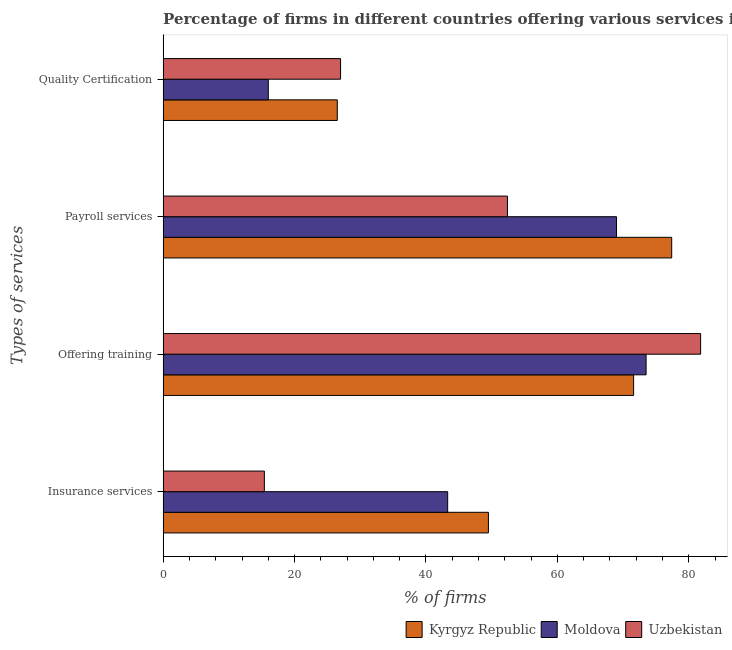How many bars are there on the 2nd tick from the bottom?
Offer a very short reply. 3. What is the label of the 4th group of bars from the top?
Give a very brief answer. Insurance services. What is the percentage of firms offering payroll services in Uzbekistan?
Keep it short and to the point. 52.4. Across all countries, what is the maximum percentage of firms offering payroll services?
Offer a terse response. 77.4. Across all countries, what is the minimum percentage of firms offering payroll services?
Keep it short and to the point. 52.4. In which country was the percentage of firms offering insurance services maximum?
Offer a terse response. Kyrgyz Republic. In which country was the percentage of firms offering quality certification minimum?
Your answer should be compact. Moldova. What is the total percentage of firms offering quality certification in the graph?
Your answer should be compact. 69.5. What is the difference between the percentage of firms offering training in Uzbekistan and that in Moldova?
Offer a terse response. 8.3. What is the average percentage of firms offering payroll services per country?
Keep it short and to the point. 66.27. What is the difference between the percentage of firms offering training and percentage of firms offering payroll services in Kyrgyz Republic?
Provide a succinct answer. -5.8. What is the ratio of the percentage of firms offering quality certification in Uzbekistan to that in Kyrgyz Republic?
Make the answer very short. 1.02. What is the difference between the highest and the second highest percentage of firms offering training?
Your answer should be compact. 8.3. What is the difference between the highest and the lowest percentage of firms offering training?
Ensure brevity in your answer.  10.2. Is the sum of the percentage of firms offering payroll services in Kyrgyz Republic and Moldova greater than the maximum percentage of firms offering quality certification across all countries?
Give a very brief answer. Yes. Is it the case that in every country, the sum of the percentage of firms offering quality certification and percentage of firms offering insurance services is greater than the sum of percentage of firms offering training and percentage of firms offering payroll services?
Your response must be concise. No. What does the 3rd bar from the top in Insurance services represents?
Ensure brevity in your answer.  Kyrgyz Republic. What does the 1st bar from the bottom in Payroll services represents?
Offer a terse response. Kyrgyz Republic. Is it the case that in every country, the sum of the percentage of firms offering insurance services and percentage of firms offering training is greater than the percentage of firms offering payroll services?
Ensure brevity in your answer.  Yes. Are all the bars in the graph horizontal?
Give a very brief answer. Yes. How many countries are there in the graph?
Your answer should be compact. 3. What is the difference between two consecutive major ticks on the X-axis?
Your answer should be very brief. 20. Are the values on the major ticks of X-axis written in scientific E-notation?
Your answer should be compact. No. Does the graph contain any zero values?
Offer a very short reply. No. Where does the legend appear in the graph?
Offer a very short reply. Bottom right. How many legend labels are there?
Keep it short and to the point. 3. How are the legend labels stacked?
Offer a terse response. Horizontal. What is the title of the graph?
Keep it short and to the point. Percentage of firms in different countries offering various services in 2003. What is the label or title of the X-axis?
Keep it short and to the point. % of firms. What is the label or title of the Y-axis?
Provide a succinct answer. Types of services. What is the % of firms of Kyrgyz Republic in Insurance services?
Keep it short and to the point. 49.5. What is the % of firms in Moldova in Insurance services?
Ensure brevity in your answer.  43.3. What is the % of firms in Kyrgyz Republic in Offering training?
Your answer should be very brief. 71.6. What is the % of firms of Moldova in Offering training?
Your response must be concise. 73.5. What is the % of firms in Uzbekistan in Offering training?
Your answer should be compact. 81.8. What is the % of firms of Kyrgyz Republic in Payroll services?
Make the answer very short. 77.4. What is the % of firms of Moldova in Payroll services?
Make the answer very short. 69. What is the % of firms in Uzbekistan in Payroll services?
Keep it short and to the point. 52.4. What is the % of firms of Kyrgyz Republic in Quality Certification?
Offer a very short reply. 26.5. What is the % of firms of Uzbekistan in Quality Certification?
Your answer should be very brief. 27. Across all Types of services, what is the maximum % of firms in Kyrgyz Republic?
Make the answer very short. 77.4. Across all Types of services, what is the maximum % of firms in Moldova?
Provide a succinct answer. 73.5. Across all Types of services, what is the maximum % of firms of Uzbekistan?
Provide a succinct answer. 81.8. Across all Types of services, what is the minimum % of firms of Moldova?
Give a very brief answer. 16. What is the total % of firms in Kyrgyz Republic in the graph?
Ensure brevity in your answer.  225. What is the total % of firms in Moldova in the graph?
Provide a succinct answer. 201.8. What is the total % of firms in Uzbekistan in the graph?
Provide a succinct answer. 176.6. What is the difference between the % of firms in Kyrgyz Republic in Insurance services and that in Offering training?
Give a very brief answer. -22.1. What is the difference between the % of firms in Moldova in Insurance services and that in Offering training?
Your answer should be very brief. -30.2. What is the difference between the % of firms of Uzbekistan in Insurance services and that in Offering training?
Keep it short and to the point. -66.4. What is the difference between the % of firms in Kyrgyz Republic in Insurance services and that in Payroll services?
Provide a succinct answer. -27.9. What is the difference between the % of firms of Moldova in Insurance services and that in Payroll services?
Your answer should be compact. -25.7. What is the difference between the % of firms in Uzbekistan in Insurance services and that in Payroll services?
Provide a succinct answer. -37. What is the difference between the % of firms of Moldova in Insurance services and that in Quality Certification?
Your response must be concise. 27.3. What is the difference between the % of firms in Kyrgyz Republic in Offering training and that in Payroll services?
Offer a very short reply. -5.8. What is the difference between the % of firms of Uzbekistan in Offering training and that in Payroll services?
Offer a very short reply. 29.4. What is the difference between the % of firms in Kyrgyz Republic in Offering training and that in Quality Certification?
Offer a very short reply. 45.1. What is the difference between the % of firms in Moldova in Offering training and that in Quality Certification?
Make the answer very short. 57.5. What is the difference between the % of firms of Uzbekistan in Offering training and that in Quality Certification?
Provide a succinct answer. 54.8. What is the difference between the % of firms of Kyrgyz Republic in Payroll services and that in Quality Certification?
Give a very brief answer. 50.9. What is the difference between the % of firms of Uzbekistan in Payroll services and that in Quality Certification?
Provide a short and direct response. 25.4. What is the difference between the % of firms of Kyrgyz Republic in Insurance services and the % of firms of Uzbekistan in Offering training?
Your answer should be very brief. -32.3. What is the difference between the % of firms in Moldova in Insurance services and the % of firms in Uzbekistan in Offering training?
Offer a very short reply. -38.5. What is the difference between the % of firms of Kyrgyz Republic in Insurance services and the % of firms of Moldova in Payroll services?
Keep it short and to the point. -19.5. What is the difference between the % of firms of Kyrgyz Republic in Insurance services and the % of firms of Moldova in Quality Certification?
Ensure brevity in your answer.  33.5. What is the difference between the % of firms of Moldova in Offering training and the % of firms of Uzbekistan in Payroll services?
Your response must be concise. 21.1. What is the difference between the % of firms in Kyrgyz Republic in Offering training and the % of firms in Moldova in Quality Certification?
Provide a succinct answer. 55.6. What is the difference between the % of firms of Kyrgyz Republic in Offering training and the % of firms of Uzbekistan in Quality Certification?
Your response must be concise. 44.6. What is the difference between the % of firms of Moldova in Offering training and the % of firms of Uzbekistan in Quality Certification?
Offer a very short reply. 46.5. What is the difference between the % of firms in Kyrgyz Republic in Payroll services and the % of firms in Moldova in Quality Certification?
Give a very brief answer. 61.4. What is the difference between the % of firms of Kyrgyz Republic in Payroll services and the % of firms of Uzbekistan in Quality Certification?
Provide a short and direct response. 50.4. What is the difference between the % of firms of Moldova in Payroll services and the % of firms of Uzbekistan in Quality Certification?
Keep it short and to the point. 42. What is the average % of firms of Kyrgyz Republic per Types of services?
Give a very brief answer. 56.25. What is the average % of firms in Moldova per Types of services?
Provide a short and direct response. 50.45. What is the average % of firms in Uzbekistan per Types of services?
Your response must be concise. 44.15. What is the difference between the % of firms in Kyrgyz Republic and % of firms in Moldova in Insurance services?
Give a very brief answer. 6.2. What is the difference between the % of firms of Kyrgyz Republic and % of firms of Uzbekistan in Insurance services?
Your answer should be very brief. 34.1. What is the difference between the % of firms of Moldova and % of firms of Uzbekistan in Insurance services?
Give a very brief answer. 27.9. What is the difference between the % of firms in Kyrgyz Republic and % of firms in Uzbekistan in Quality Certification?
Keep it short and to the point. -0.5. What is the difference between the % of firms of Moldova and % of firms of Uzbekistan in Quality Certification?
Offer a terse response. -11. What is the ratio of the % of firms in Kyrgyz Republic in Insurance services to that in Offering training?
Provide a short and direct response. 0.69. What is the ratio of the % of firms of Moldova in Insurance services to that in Offering training?
Ensure brevity in your answer.  0.59. What is the ratio of the % of firms of Uzbekistan in Insurance services to that in Offering training?
Provide a short and direct response. 0.19. What is the ratio of the % of firms of Kyrgyz Republic in Insurance services to that in Payroll services?
Provide a short and direct response. 0.64. What is the ratio of the % of firms in Moldova in Insurance services to that in Payroll services?
Keep it short and to the point. 0.63. What is the ratio of the % of firms of Uzbekistan in Insurance services to that in Payroll services?
Provide a short and direct response. 0.29. What is the ratio of the % of firms of Kyrgyz Republic in Insurance services to that in Quality Certification?
Your answer should be compact. 1.87. What is the ratio of the % of firms of Moldova in Insurance services to that in Quality Certification?
Make the answer very short. 2.71. What is the ratio of the % of firms of Uzbekistan in Insurance services to that in Quality Certification?
Your answer should be compact. 0.57. What is the ratio of the % of firms in Kyrgyz Republic in Offering training to that in Payroll services?
Your response must be concise. 0.93. What is the ratio of the % of firms of Moldova in Offering training to that in Payroll services?
Provide a succinct answer. 1.07. What is the ratio of the % of firms in Uzbekistan in Offering training to that in Payroll services?
Provide a short and direct response. 1.56. What is the ratio of the % of firms of Kyrgyz Republic in Offering training to that in Quality Certification?
Ensure brevity in your answer.  2.7. What is the ratio of the % of firms of Moldova in Offering training to that in Quality Certification?
Make the answer very short. 4.59. What is the ratio of the % of firms in Uzbekistan in Offering training to that in Quality Certification?
Ensure brevity in your answer.  3.03. What is the ratio of the % of firms of Kyrgyz Republic in Payroll services to that in Quality Certification?
Your answer should be compact. 2.92. What is the ratio of the % of firms in Moldova in Payroll services to that in Quality Certification?
Make the answer very short. 4.31. What is the ratio of the % of firms of Uzbekistan in Payroll services to that in Quality Certification?
Keep it short and to the point. 1.94. What is the difference between the highest and the second highest % of firms of Kyrgyz Republic?
Make the answer very short. 5.8. What is the difference between the highest and the second highest % of firms in Uzbekistan?
Offer a very short reply. 29.4. What is the difference between the highest and the lowest % of firms of Kyrgyz Republic?
Provide a succinct answer. 50.9. What is the difference between the highest and the lowest % of firms of Moldova?
Your response must be concise. 57.5. What is the difference between the highest and the lowest % of firms of Uzbekistan?
Make the answer very short. 66.4. 